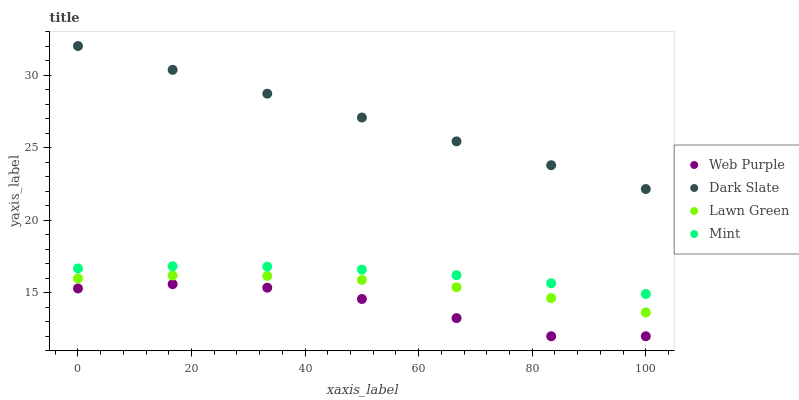Does Web Purple have the minimum area under the curve?
Answer yes or no. Yes. Does Dark Slate have the maximum area under the curve?
Answer yes or no. Yes. Does Mint have the minimum area under the curve?
Answer yes or no. No. Does Mint have the maximum area under the curve?
Answer yes or no. No. Is Dark Slate the smoothest?
Answer yes or no. Yes. Is Web Purple the roughest?
Answer yes or no. Yes. Is Mint the smoothest?
Answer yes or no. No. Is Mint the roughest?
Answer yes or no. No. Does Web Purple have the lowest value?
Answer yes or no. Yes. Does Mint have the lowest value?
Answer yes or no. No. Does Dark Slate have the highest value?
Answer yes or no. Yes. Does Mint have the highest value?
Answer yes or no. No. Is Mint less than Dark Slate?
Answer yes or no. Yes. Is Mint greater than Lawn Green?
Answer yes or no. Yes. Does Mint intersect Dark Slate?
Answer yes or no. No. 